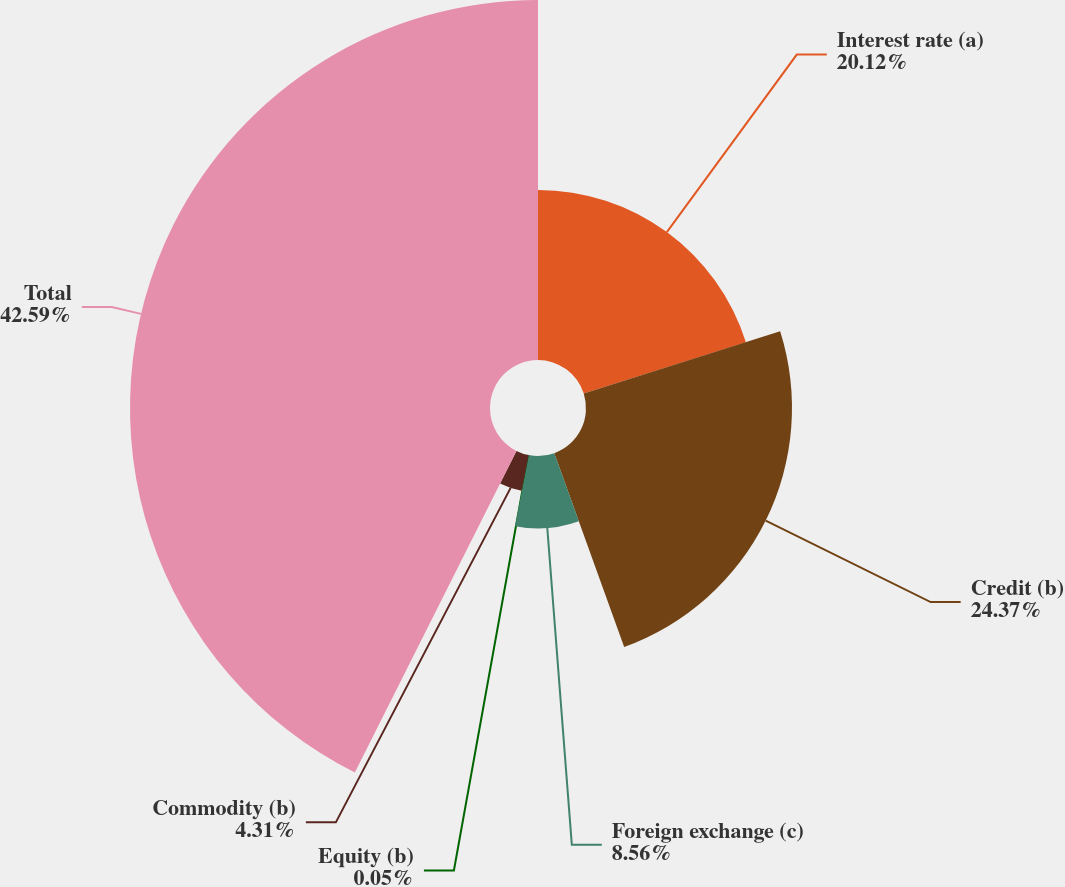Convert chart. <chart><loc_0><loc_0><loc_500><loc_500><pie_chart><fcel>Interest rate (a)<fcel>Credit (b)<fcel>Foreign exchange (c)<fcel>Equity (b)<fcel>Commodity (b)<fcel>Total<nl><fcel>20.12%<fcel>24.37%<fcel>8.56%<fcel>0.05%<fcel>4.31%<fcel>42.59%<nl></chart> 